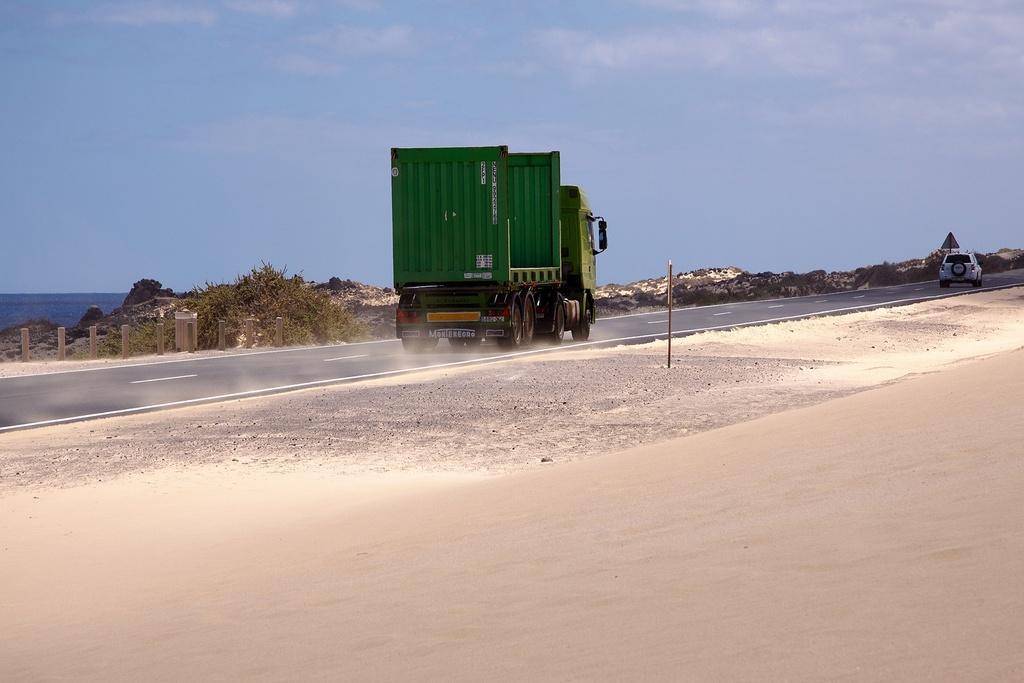In one or two sentences, can you explain what this image depicts? In this image at the bottom there is a road and sand, and in the center there is one vehicle. In the background there are some mountains, on the right side there is one vehicle. On the top of the image there is sky. 